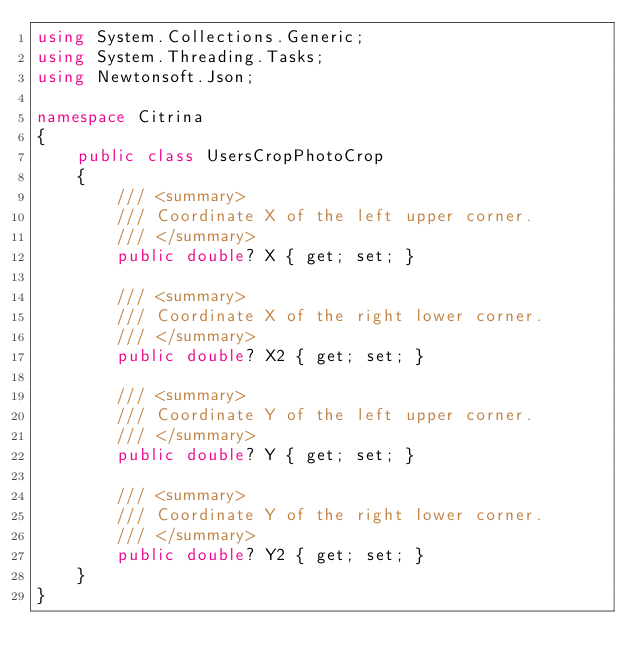<code> <loc_0><loc_0><loc_500><loc_500><_C#_>using System.Collections.Generic;
using System.Threading.Tasks;
using Newtonsoft.Json;

namespace Citrina
{
    public class UsersCropPhotoCrop
    {
        /// <summary>
        /// Coordinate X of the left upper corner.
        /// </summary>
        public double? X { get; set; } 

        /// <summary>
        /// Coordinate X of the right lower corner.
        /// </summary>
        public double? X2 { get; set; } 

        /// <summary>
        /// Coordinate Y of the left upper corner.
        /// </summary>
        public double? Y { get; set; } 

        /// <summary>
        /// Coordinate Y of the right lower corner.
        /// </summary>
        public double? Y2 { get; set; } 
    }
}
</code> 